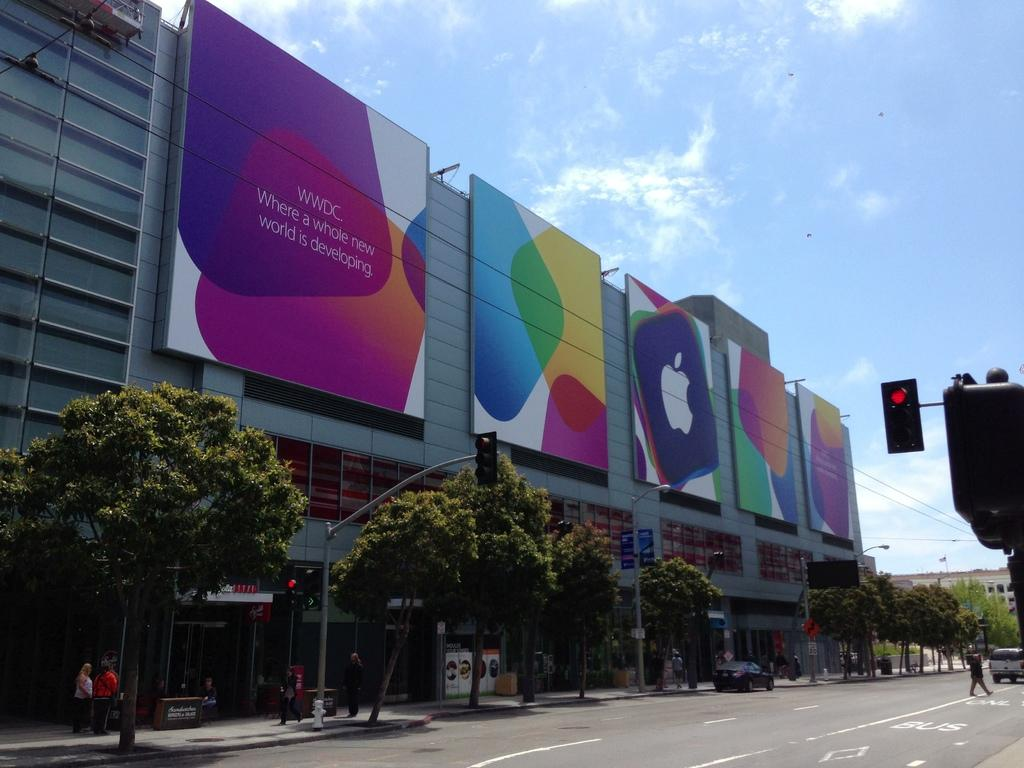<image>
Render a clear and concise summary of the photo. The sign claims a whole new world is developing here. 